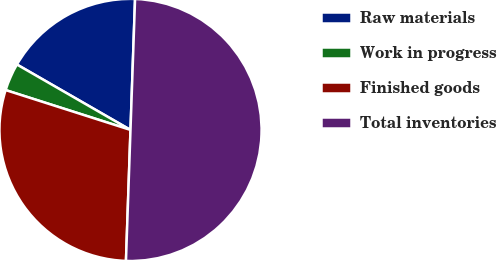<chart> <loc_0><loc_0><loc_500><loc_500><pie_chart><fcel>Raw materials<fcel>Work in progress<fcel>Finished goods<fcel>Total inventories<nl><fcel>17.24%<fcel>3.4%<fcel>29.37%<fcel>50.0%<nl></chart> 